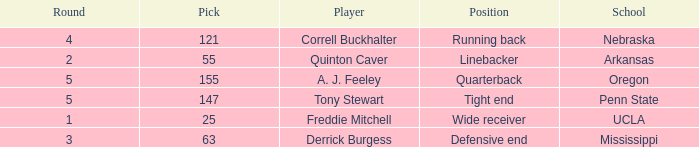What position did a. j. feeley play who was picked in round 5? Quarterback. 